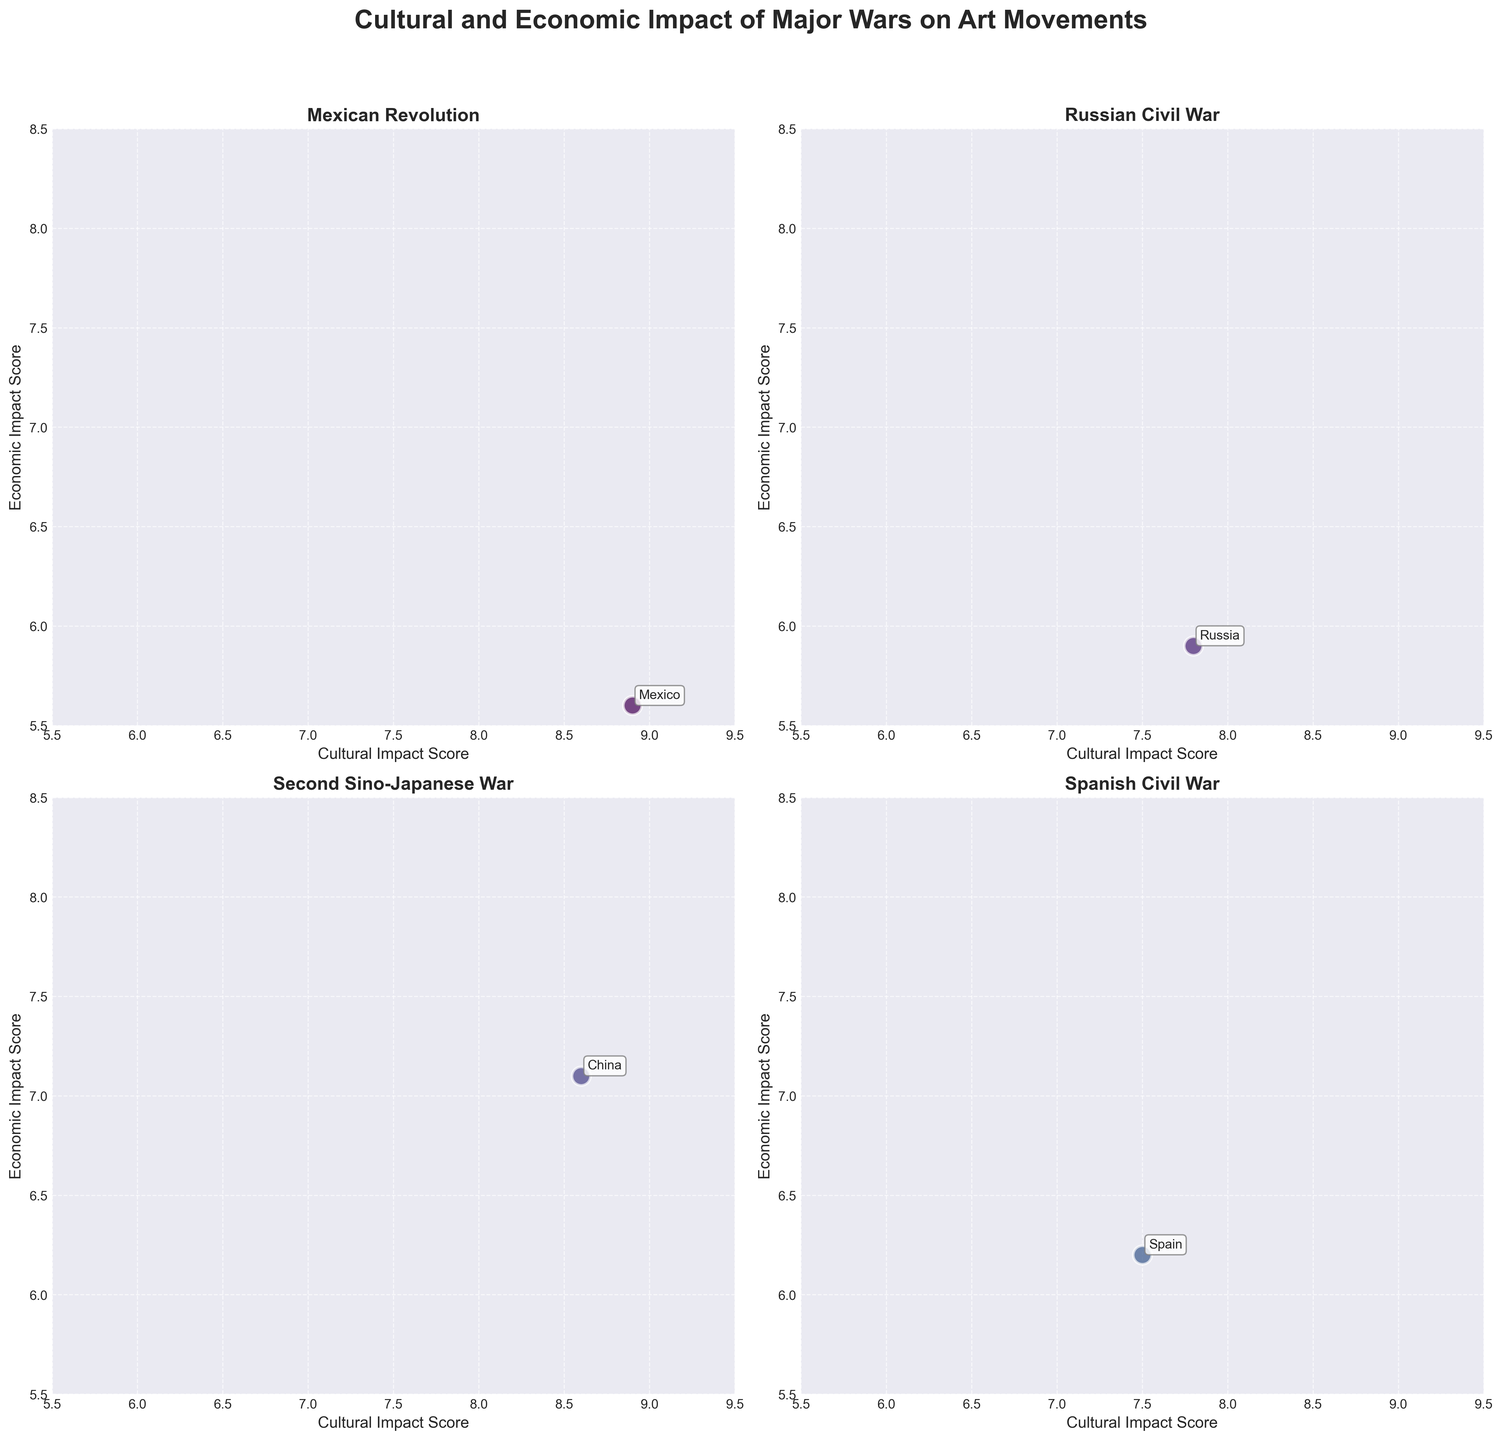Is there any war with both low cultural and economic impact scores? Look at the scatter plots for data points within low ranges (both axes below around 6.5). Check if any point exists in that quadrant.
Answer: No Which country has the highest cultural impact score in World War II? Look at the World War II subplot and find the data point with the highest cultural impact axis value.
Answer: USA How does the cultural impact of Vorticism in the UK compare to Dadaism in France during World War I? Compare the "Cultural Impact Score" for both data points in the World War I subplot.
Answer: Vorticism: 6.9, Dadaism: 8.2 What is the total number of countries represented in the "Vietnam War" subplot? Count the number of countries listed in the Vietnam War subplot.
Answer: 1 Which war resulted in the highest economic impact score for any country? Look across all subplots for the highest value in the "Economic Impact Score" axis.
Answer: World War II (Germany) What is the average economic impact score for World War I? Sum the "Economic Impact Score" values for World War I countries, then divide by the number of data points (France and UK).
Answer: (7.5 + 6.5) / 2 = 7.0 Which art movement is associated with the highest cultural impact score in the Second Sino-Japanese War subplot? Check the cultural impact scores, and then identify the associated art movement.
Answer: Revolutionary Realism Are there more countries with a cultural impact score higher than 8.0 or economic impact score higher than 7.5 in the Russian Civil War subplot? Compare the count of data points where "Cultural Impact Score" > 8.0 versus those where "Economic Impact Score" > 7.5.
Answer: Cultural Impact > 8.0: 0, Economic Impact > 7.5: 0 Is the cultural impact score for Surrealism in Spain closer to the highest or lowest cultural impact score depicted in all wars? Compare the Surrealism (Spain) value with both the highest and lowest cultural impact scores across all subplots.
Answer: Closer to Lowest Which war has the greatest range in economic impact scores among countries represented? Calculate the range (max - min) for economic impact scores in all subplots and determine the highest range.
Answer: World War II (8.3 - 6.0 = 2.3) 